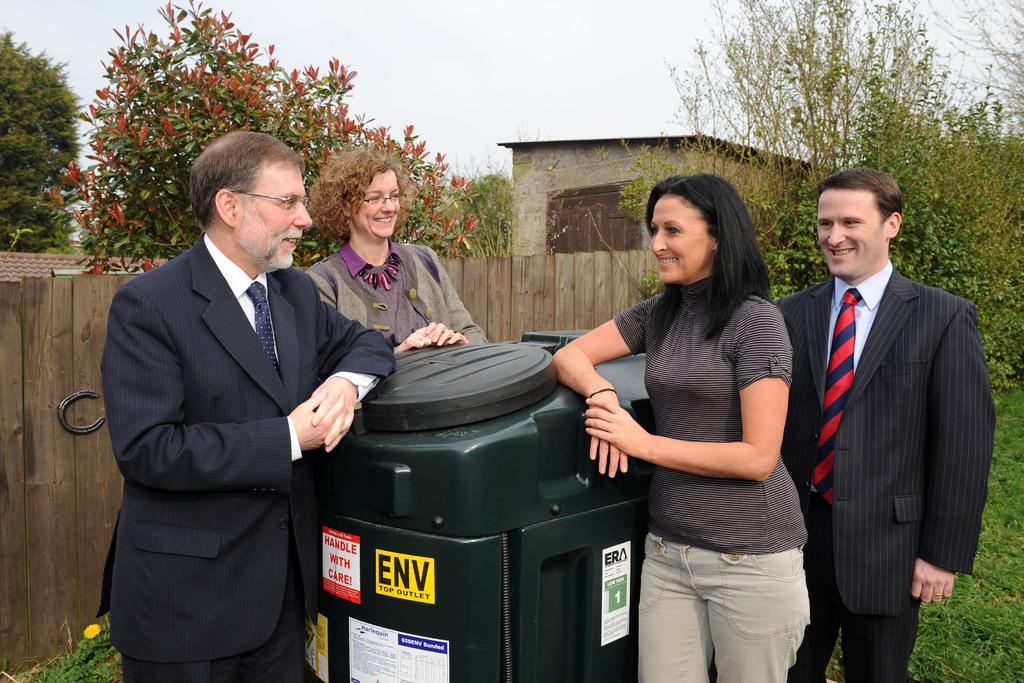What letters are on the yellow sticker?
Provide a short and direct response. Env. How should you handle this container?
Keep it short and to the point. With care. 